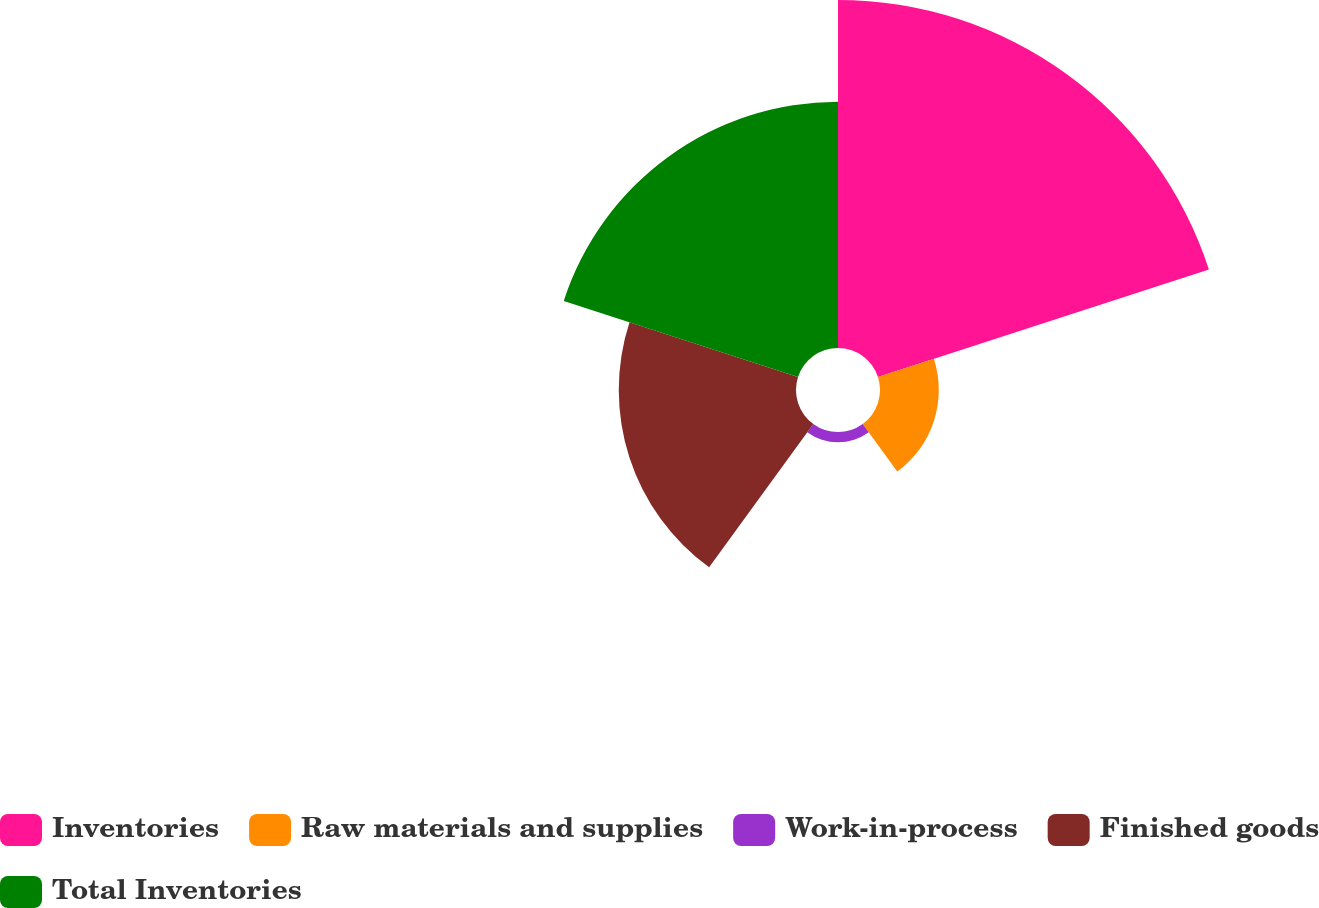Convert chart to OTSL. <chart><loc_0><loc_0><loc_500><loc_500><pie_chart><fcel>Inventories<fcel>Raw materials and supplies<fcel>Work-in-process<fcel>Finished goods<fcel>Total Inventories<nl><fcel>41.39%<fcel>6.99%<fcel>1.23%<fcel>21.08%<fcel>29.3%<nl></chart> 